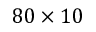<formula> <loc_0><loc_0><loc_500><loc_500>8 0 \times 1 0</formula> 